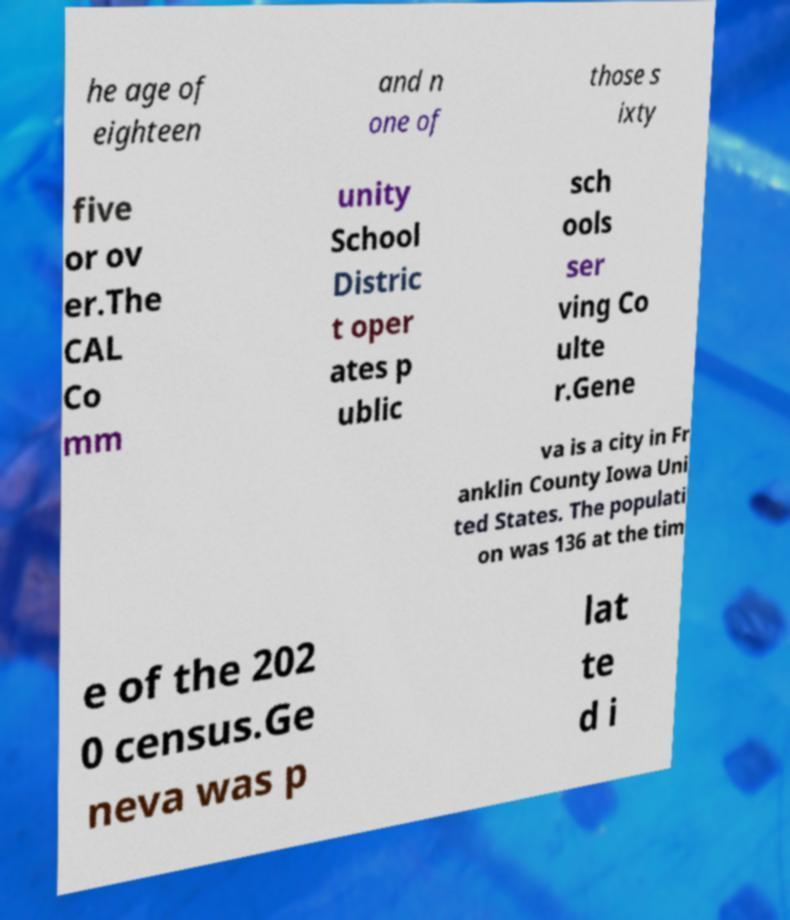What messages or text are displayed in this image? I need them in a readable, typed format. he age of eighteen and n one of those s ixty five or ov er.The CAL Co mm unity School Distric t oper ates p ublic sch ools ser ving Co ulte r.Gene va is a city in Fr anklin County Iowa Uni ted States. The populati on was 136 at the tim e of the 202 0 census.Ge neva was p lat te d i 